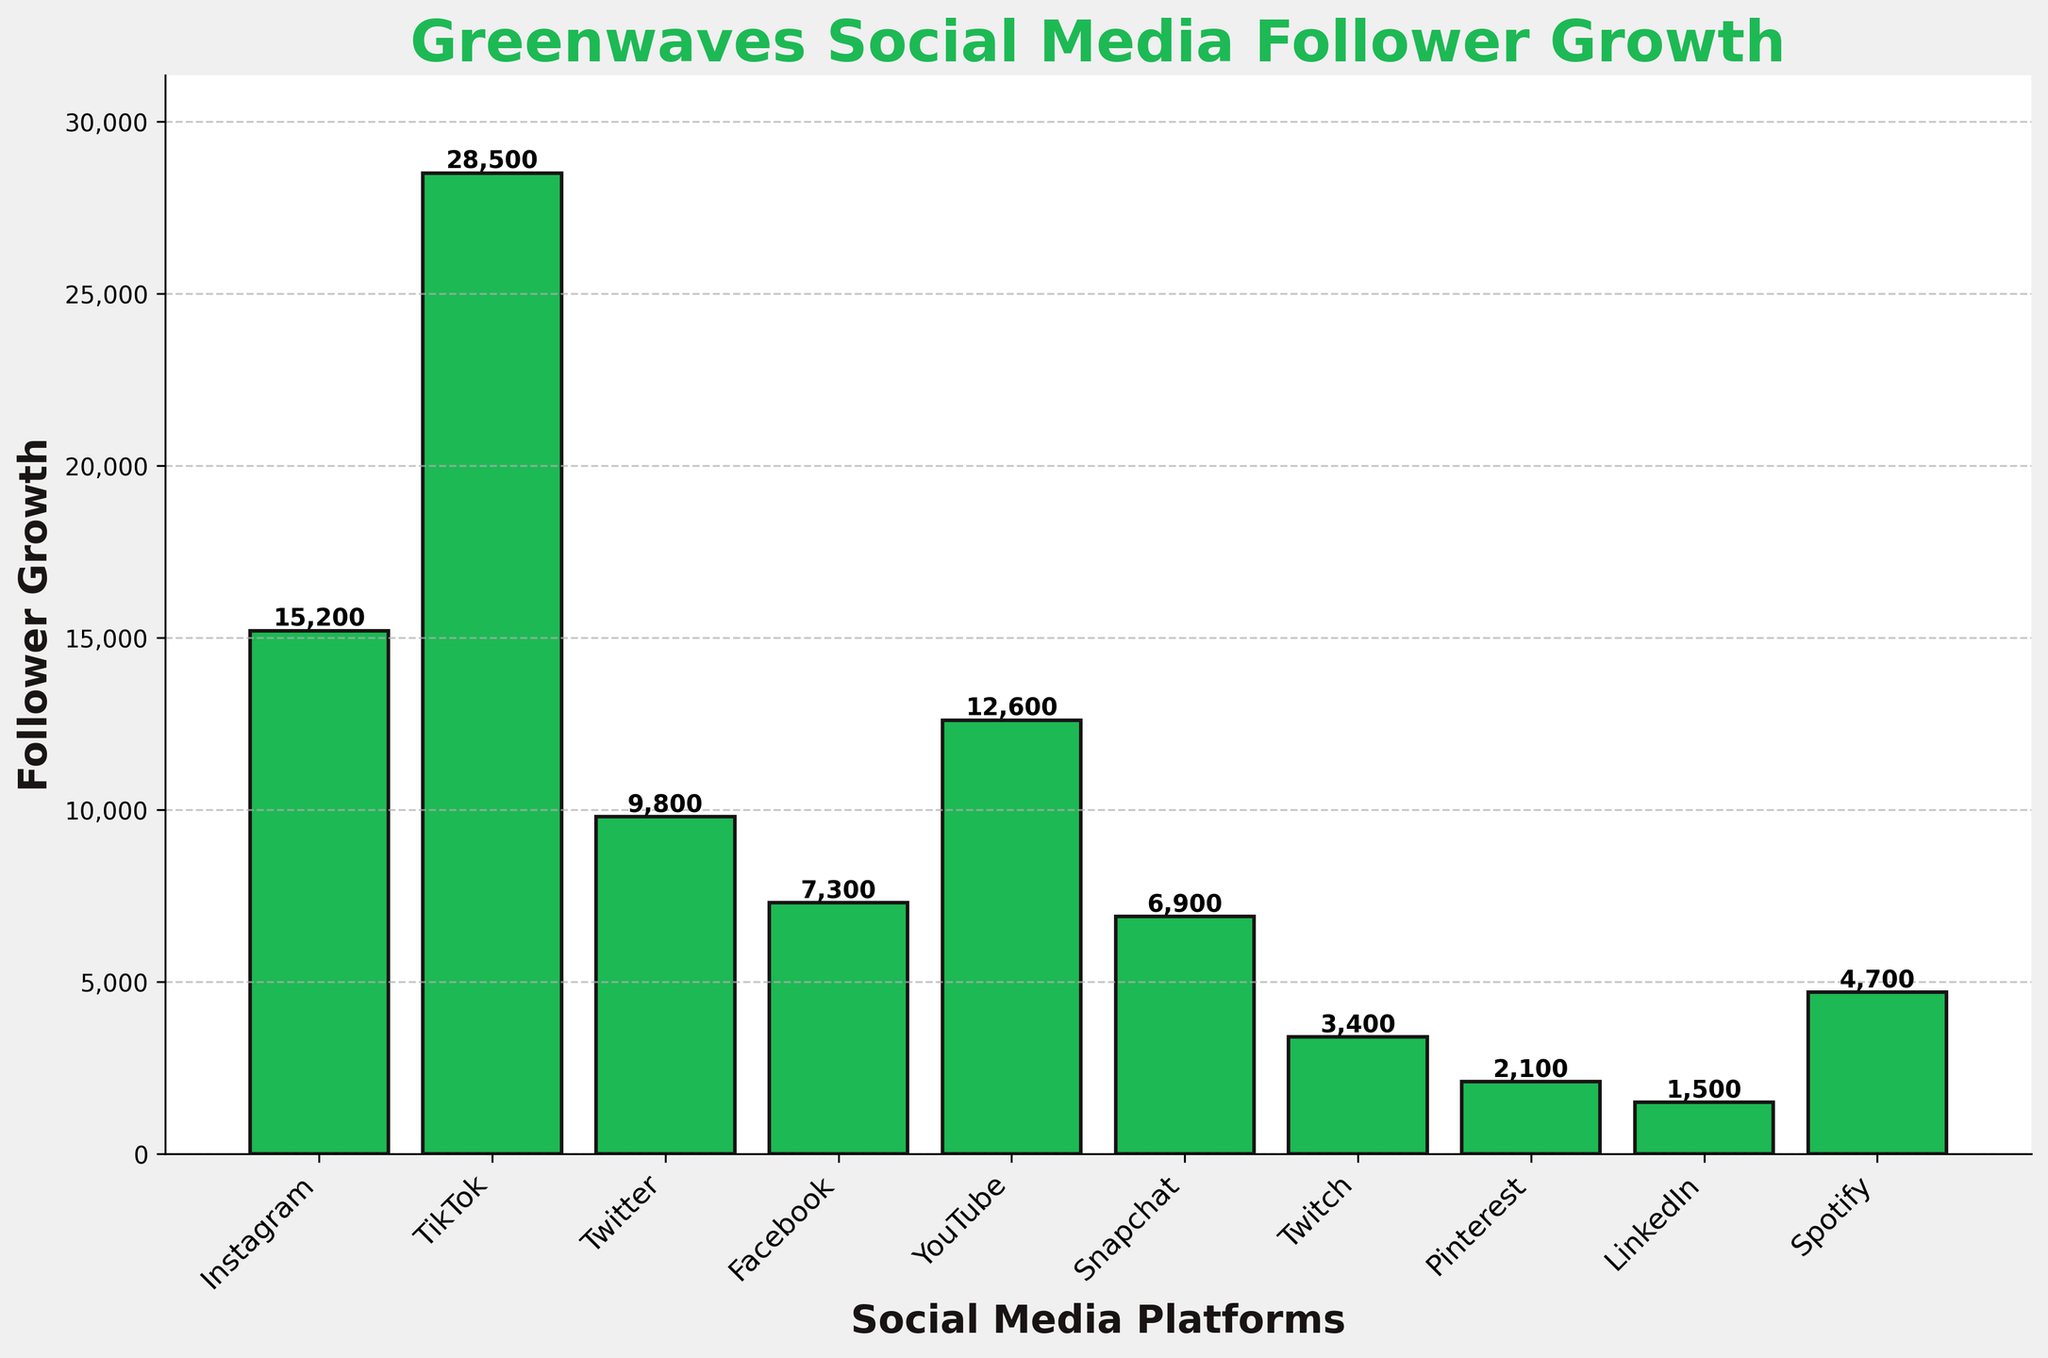Which social media platform has the highest follower growth for Greenwaves? By inspecting the height of the bar representing each platform, we can see that TikTok has the tallest bar, indicating it has the highest follower growth among all platforms.
Answer: TikTok Which social media platform has the lowest follower growth for Greenwaves? The shortest bar among all the platforms is for LinkedIn, indicating it has the lowest follower growth.
Answer: LinkedIn What is the difference in follower growth between Instagram and Facebook? To find the difference in follower growth, we look at the height of Instagram's bar (15,200) and Facebook's bar (7,300) and subtract the two values: 15,200 - 7,300.
Answer: 7,900 How much higher is the follower growth for TikTok compared to YouTube? TikTok's follower growth is 28,500, and YouTube's is 12,600. The difference can be calculated as 28,500 - 12,600.
Answer: 15,900 What is the sum of follower growth for Twitter, Snapchat, and Spotify? By adding the follower growth numbers for Twitter (9,800), Snapchat (6,900), and Spotify (4,700), we get the total: 9,800 + 6,900 + 4,700.
Answer: 21,400 In which range do most of the platforms' follower growth values fall: below 10,000 or above 10,000? By examining the relative heights of the bars, we can see that the majority of the platforms (Twitter, Facebook, Snapchat, Twitch, Pinterest, LinkedIn, and Spotify) have follower growth values below 10,000.
Answer: Below 10,000 How is the bar representing Facebook visually distinct in color compared to Twitch? All bars are the same green color, adhering to the consistent color scheme used in the plot.
Answer: Same color Rank the top three platforms based on follower growth. By comparing the heights of all bars, TikTok has the highest follower growth, followed by Instagram, and then YouTube.
Answer: TikTok, Instagram, YouTube What is the average follower growth across all platforms represented in the chart? Adding the follower growth values for all platforms (15,200 + 28,500 + 9,800 + 7,300 + 12,600 + 6,900 + 3,400 + 2,100 + 1,500 + 4,700) gives a total of 92,000. Dividing this sum by the number of platforms (10) provides the average: 92,000 / 10.
Answer: 9,200 Which has a greater follower growth: the combined total of Pinterest and LinkedIn or Snapchat alone? Adding Pinterest's (2,100) and LinkedIn's (1,500) follower growth gives 3,600. Snapchat alone has 6,900. Comparing the two, Snapchat's follower growth is greater.
Answer: Snapchat alone 